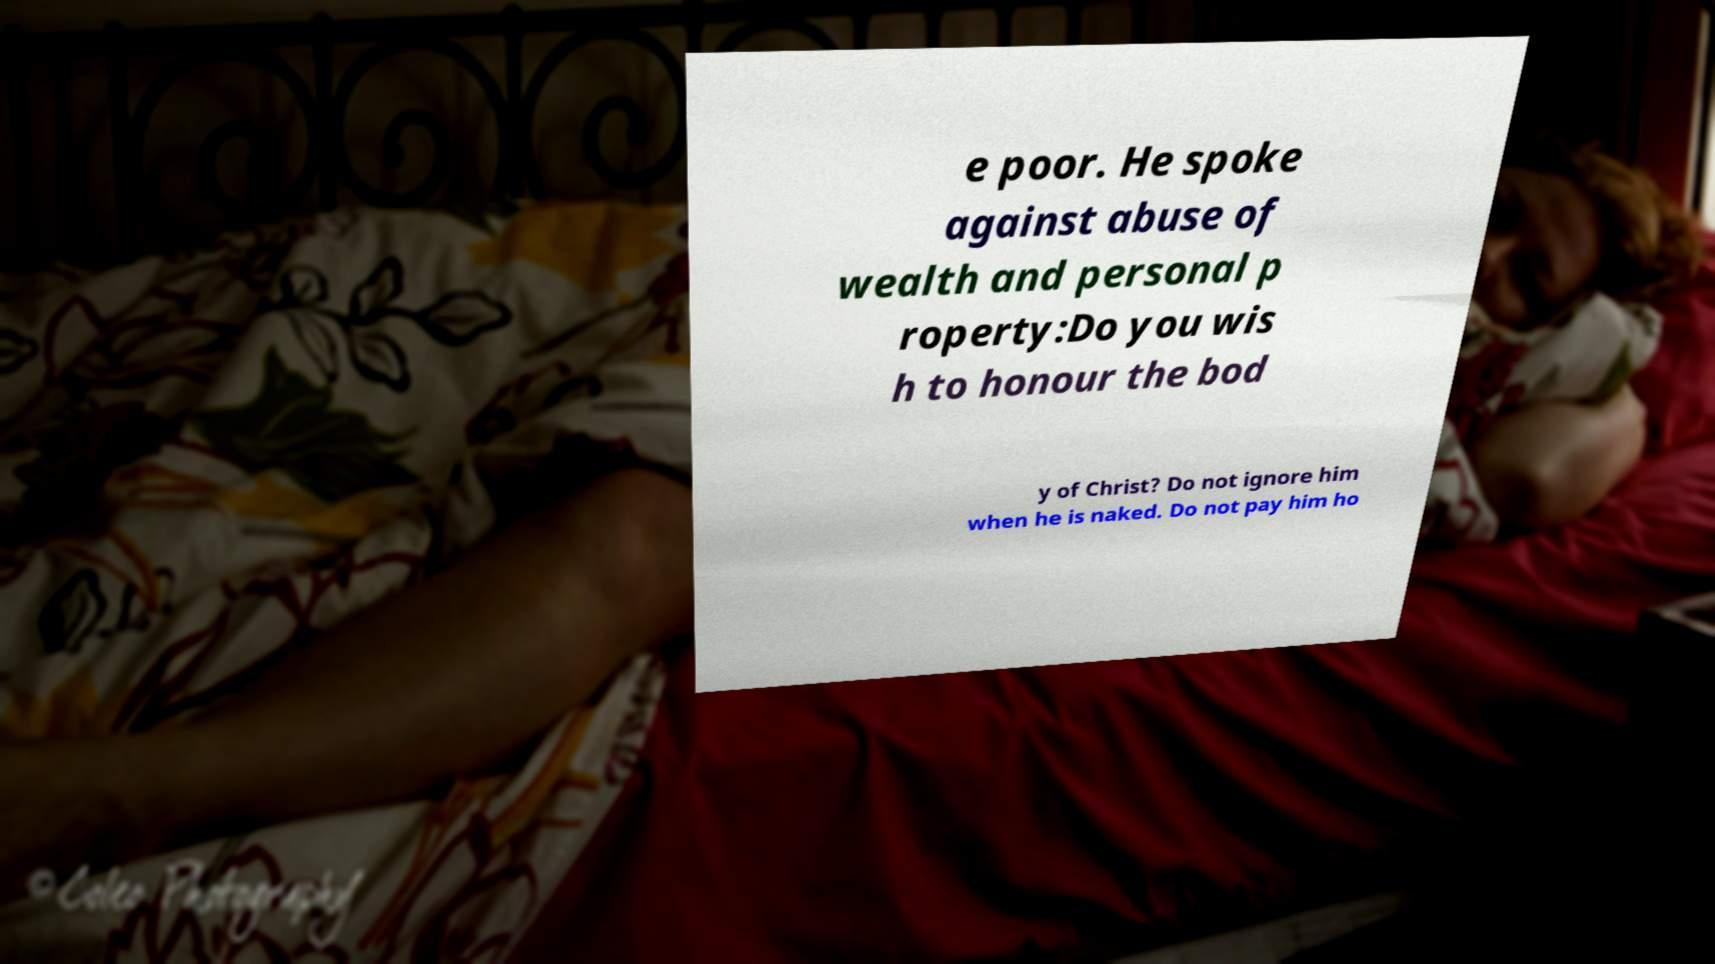For documentation purposes, I need the text within this image transcribed. Could you provide that? e poor. He spoke against abuse of wealth and personal p roperty:Do you wis h to honour the bod y of Christ? Do not ignore him when he is naked. Do not pay him ho 